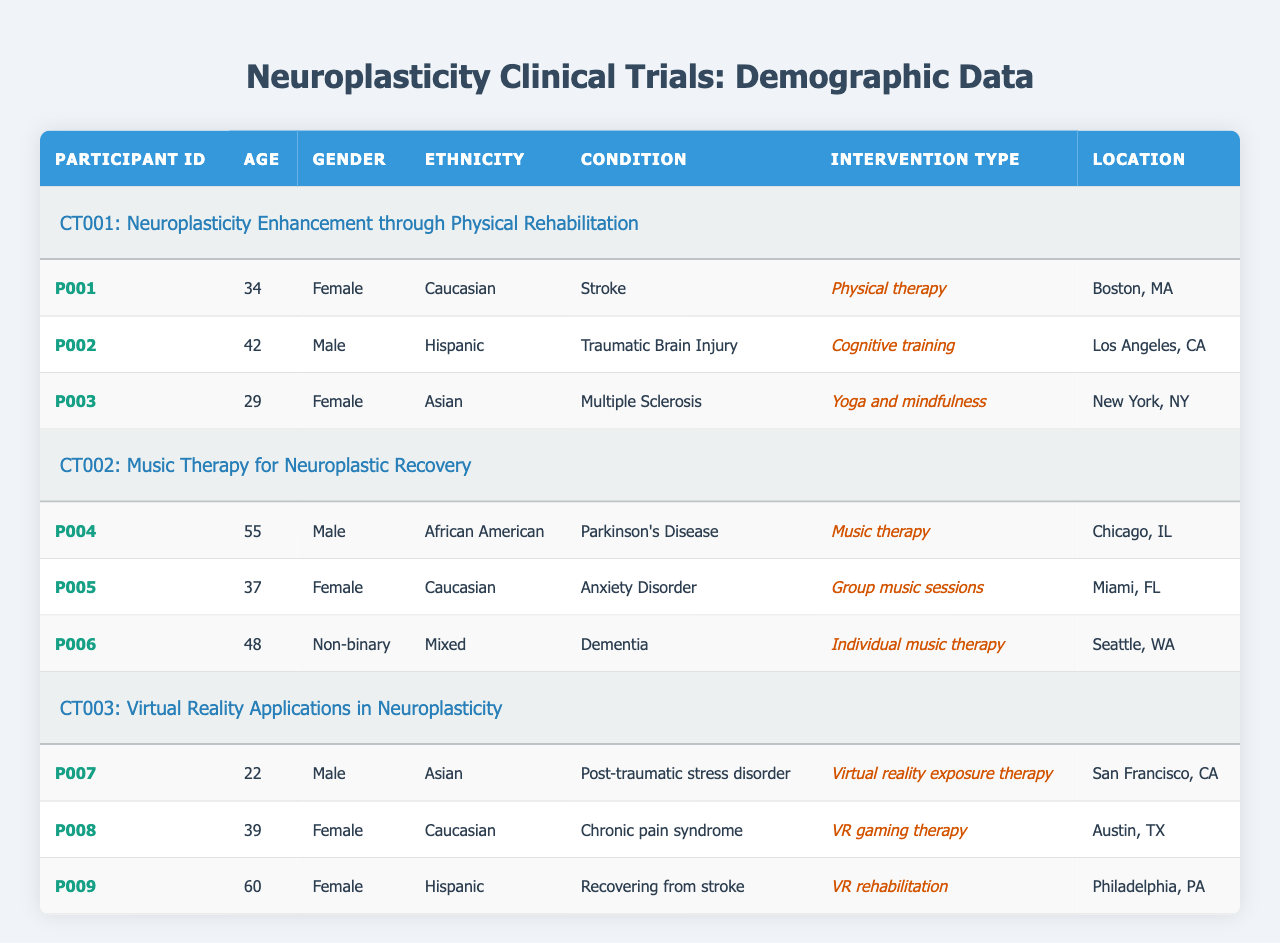What is the age of the oldest participant? The data shows that the oldest participant is P009, who is 60 years old.
Answer: 60 How many male participants are there in the trials? From the table, there are three male participants: P002, P004, and P007.
Answer: 3 What types of interventions are used in CT001? The table indicates that participants P001, P002, and P003 underwent the interventions of physical therapy, cognitive training, and yoga and mindfulness, respectively, in study CT001.
Answer: Physical therapy, Cognitive training, Yoga and mindfulness Is there any participant with a non-binary gender? Yes, participant P006 is classified as non-binary based on the information provided.
Answer: Yes Which location has the highest number of participants? There are 3 participants located in Boston, MA and 3 in Los Angeles, CA, making them tied for the highest count.
Answer: Boston, MA and Los Angeles, CA (tie) What condition is associated with the youngest participant? Participant P007 is the youngest at age 22 and has the condition of post-traumatic stress disorder.
Answer: Post-traumatic stress disorder Count the total number of female participants. The table lists five female participants: P001, P003, P005, P008, and P009.
Answer: 5 Are there more than two participants receiving music therapy? There are two participants receiving music therapy: P004 and P006. Hence, the statement is false.
Answer: No What is the average age of participants in CT002? The ages of participants in CT002 are 55 (P004), 37 (P005), and 48 (P006). To find the average, sum the ages (55 + 37 + 48 = 140) and divide by the number of participants (3), resulting in an average age of 46.67.
Answer: 46.67 Compare the age of the participants in CT003 to CT001. Is the average age of participants in CT001 higher? In CT001, the ages are 34, 42, and 29 (average = 35). In CT003, the ages are 22, 39, and 60 (average = 40.33). Since 35 is less than 40.33, the average age in CT001 is not higher.
Answer: No 